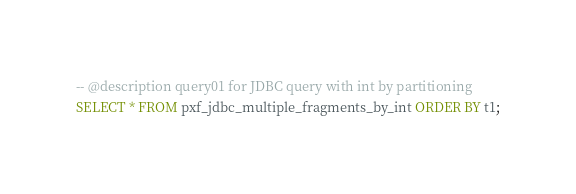Convert code to text. <code><loc_0><loc_0><loc_500><loc_500><_SQL_>-- @description query01 for JDBC query with int by partitioning
SELECT * FROM pxf_jdbc_multiple_fragments_by_int ORDER BY t1;
</code> 